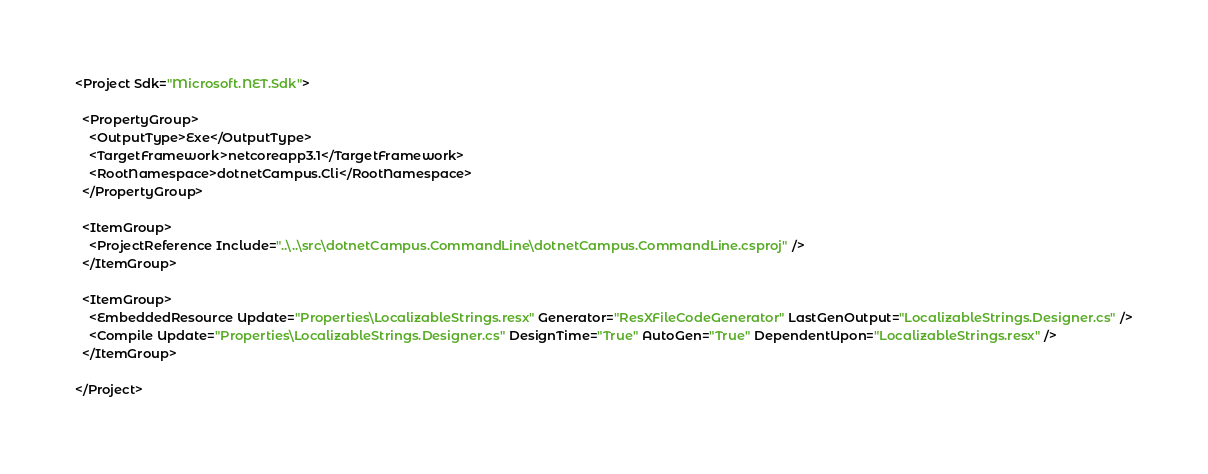<code> <loc_0><loc_0><loc_500><loc_500><_XML_><Project Sdk="Microsoft.NET.Sdk">

  <PropertyGroup>
    <OutputType>Exe</OutputType>
    <TargetFramework>netcoreapp3.1</TargetFramework>
    <RootNamespace>dotnetCampus.Cli</RootNamespace>
  </PropertyGroup>

  <ItemGroup>
    <ProjectReference Include="..\..\src\dotnetCampus.CommandLine\dotnetCampus.CommandLine.csproj" />
  </ItemGroup>

  <ItemGroup>
    <EmbeddedResource Update="Properties\LocalizableStrings.resx" Generator="ResXFileCodeGenerator" LastGenOutput="LocalizableStrings.Designer.cs" />
    <Compile Update="Properties\LocalizableStrings.Designer.cs" DesignTime="True" AutoGen="True" DependentUpon="LocalizableStrings.resx" />
  </ItemGroup>

</Project>
</code> 